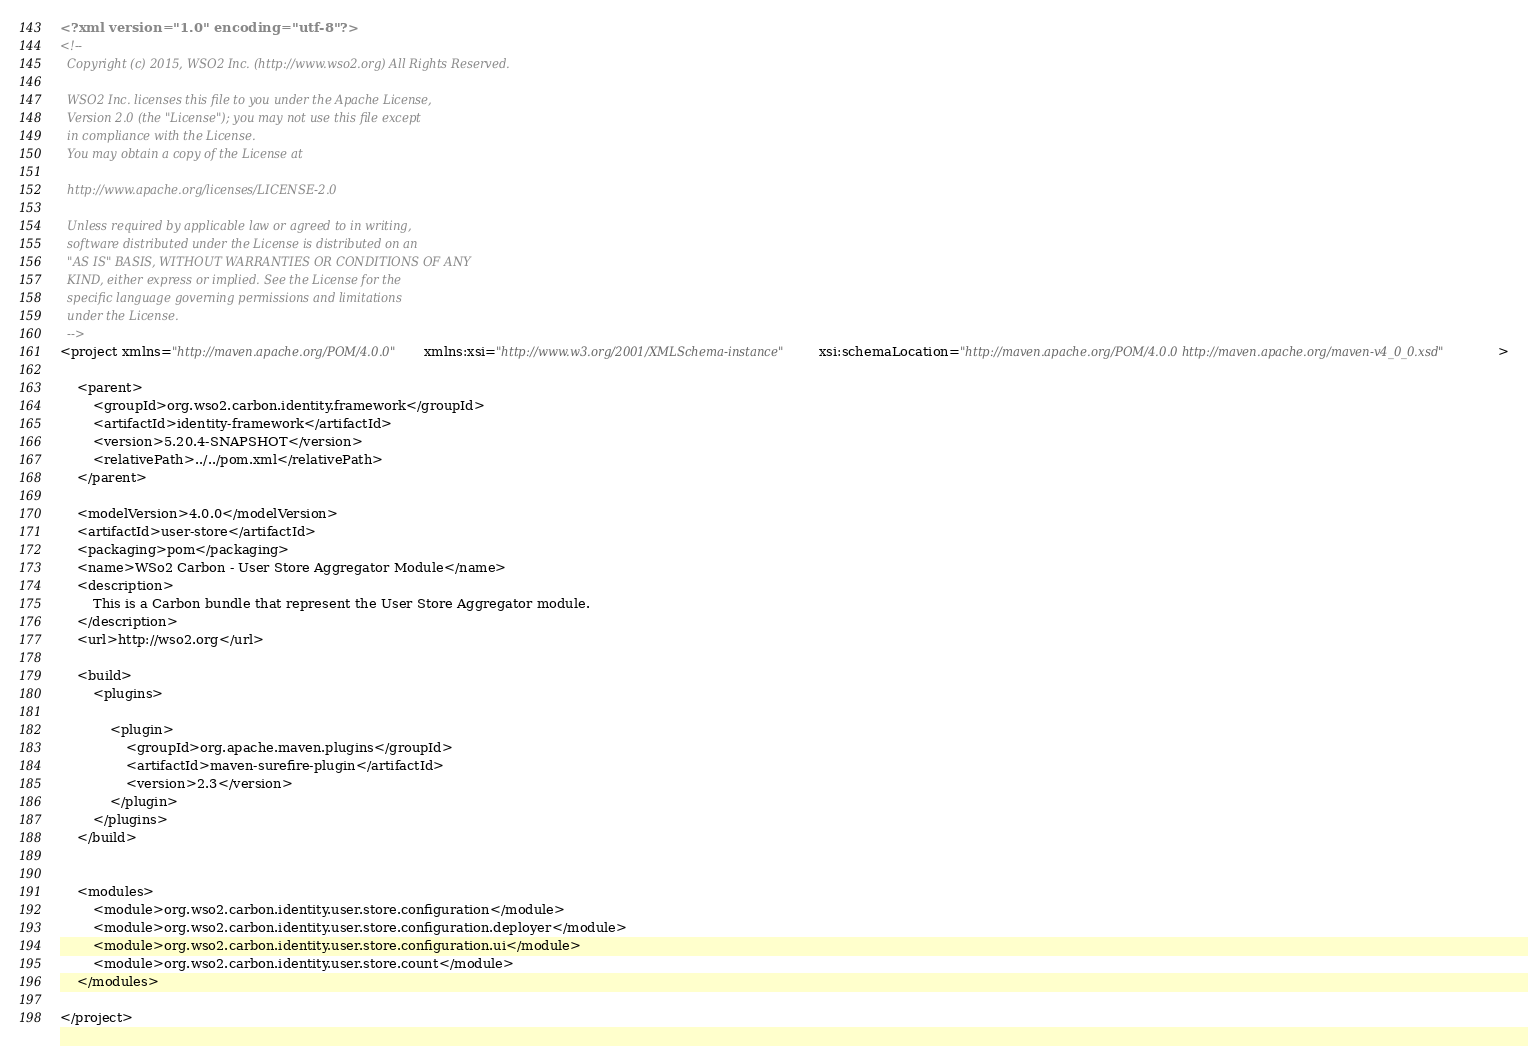<code> <loc_0><loc_0><loc_500><loc_500><_XML_><?xml version="1.0" encoding="utf-8"?>
<!--
  Copyright (c) 2015, WSO2 Inc. (http://www.wso2.org) All Rights Reserved.

  WSO2 Inc. licenses this file to you under the Apache License,
  Version 2.0 (the "License"); you may not use this file except
  in compliance with the License.
  You may obtain a copy of the License at

  http://www.apache.org/licenses/LICENSE-2.0

  Unless required by applicable law or agreed to in writing,
  software distributed under the License is distributed on an
  "AS IS" BASIS, WITHOUT WARRANTIES OR CONDITIONS OF ANY
  KIND, either express or implied. See the License for the
  specific language governing permissions and limitations
  under the License.
  -->
<project xmlns="http://maven.apache.org/POM/4.0.0" xmlns:xsi="http://www.w3.org/2001/XMLSchema-instance" xsi:schemaLocation="http://maven.apache.org/POM/4.0.0 http://maven.apache.org/maven-v4_0_0.xsd">

    <parent>
        <groupId>org.wso2.carbon.identity.framework</groupId>
        <artifactId>identity-framework</artifactId>
        <version>5.20.4-SNAPSHOT</version>
        <relativePath>../../pom.xml</relativePath>
    </parent>

    <modelVersion>4.0.0</modelVersion>
    <artifactId>user-store</artifactId>
    <packaging>pom</packaging>
    <name>WSo2 Carbon - User Store Aggregator Module</name>
    <description>
        This is a Carbon bundle that represent the User Store Aggregator module.
    </description>
    <url>http://wso2.org</url>

    <build>
        <plugins>

            <plugin>
                <groupId>org.apache.maven.plugins</groupId>
                <artifactId>maven-surefire-plugin</artifactId>
                <version>2.3</version>
            </plugin>
        </plugins>
    </build>


    <modules>
        <module>org.wso2.carbon.identity.user.store.configuration</module>
        <module>org.wso2.carbon.identity.user.store.configuration.deployer</module>
        <module>org.wso2.carbon.identity.user.store.configuration.ui</module>
        <module>org.wso2.carbon.identity.user.store.count</module>
    </modules>

</project>
</code> 